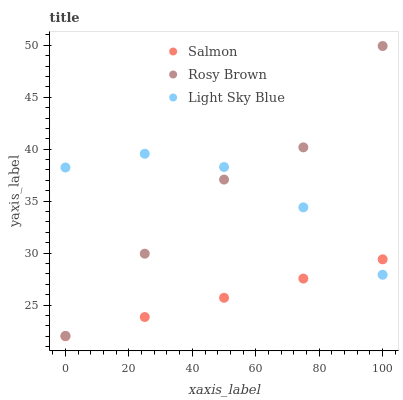Does Salmon have the minimum area under the curve?
Answer yes or no. Yes. Does Light Sky Blue have the maximum area under the curve?
Answer yes or no. Yes. Does Light Sky Blue have the minimum area under the curve?
Answer yes or no. No. Does Salmon have the maximum area under the curve?
Answer yes or no. No. Is Salmon the smoothest?
Answer yes or no. Yes. Is Rosy Brown the roughest?
Answer yes or no. Yes. Is Light Sky Blue the smoothest?
Answer yes or no. No. Is Light Sky Blue the roughest?
Answer yes or no. No. Does Salmon have the lowest value?
Answer yes or no. Yes. Does Light Sky Blue have the lowest value?
Answer yes or no. No. Does Rosy Brown have the highest value?
Answer yes or no. Yes. Does Light Sky Blue have the highest value?
Answer yes or no. No. Is Salmon less than Rosy Brown?
Answer yes or no. Yes. Is Rosy Brown greater than Salmon?
Answer yes or no. Yes. Does Light Sky Blue intersect Rosy Brown?
Answer yes or no. Yes. Is Light Sky Blue less than Rosy Brown?
Answer yes or no. No. Is Light Sky Blue greater than Rosy Brown?
Answer yes or no. No. Does Salmon intersect Rosy Brown?
Answer yes or no. No. 